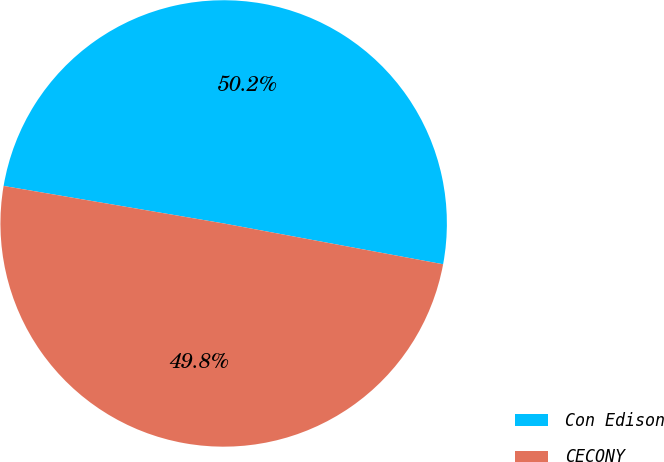Convert chart. <chart><loc_0><loc_0><loc_500><loc_500><pie_chart><fcel>Con Edison<fcel>CECONY<nl><fcel>50.24%<fcel>49.76%<nl></chart> 